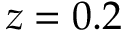<formula> <loc_0><loc_0><loc_500><loc_500>z = 0 . 2</formula> 